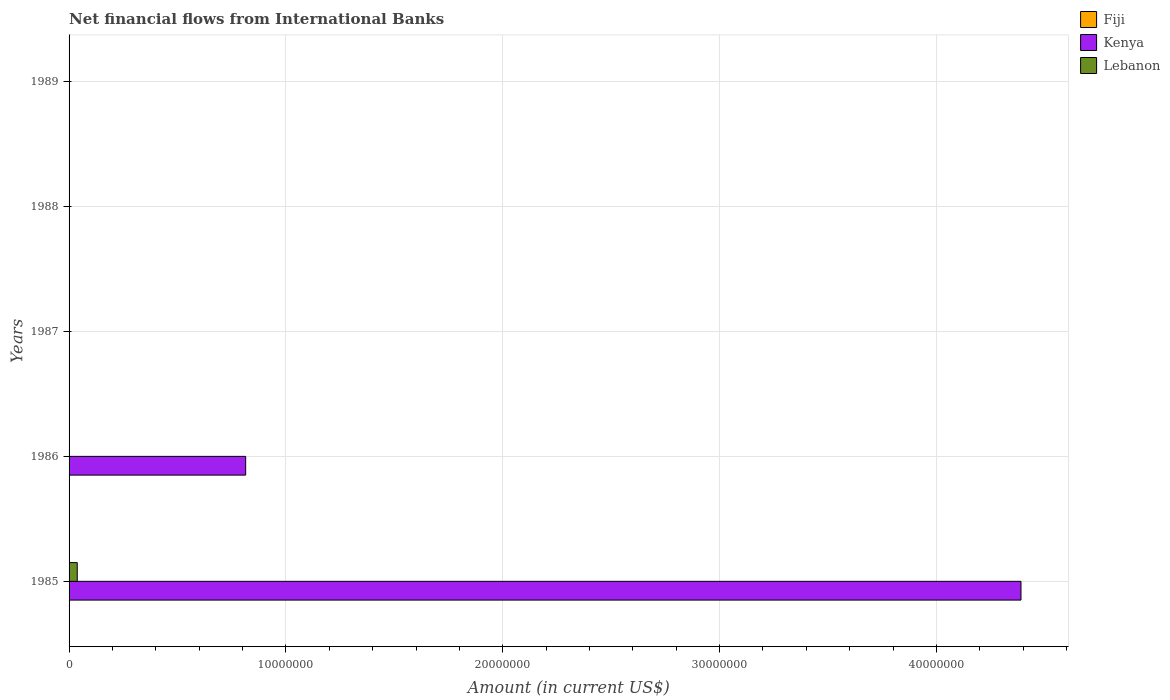How many bars are there on the 1st tick from the top?
Provide a short and direct response. 0. How many bars are there on the 5th tick from the bottom?
Give a very brief answer. 0. In how many cases, is the number of bars for a given year not equal to the number of legend labels?
Give a very brief answer. 5. Across all years, what is the maximum net financial aid flows in Lebanon?
Your response must be concise. 3.77e+05. Across all years, what is the minimum net financial aid flows in Lebanon?
Offer a very short reply. 0. What is the total net financial aid flows in Lebanon in the graph?
Give a very brief answer. 3.77e+05. What is the difference between the net financial aid flows in Kenya in 1987 and the net financial aid flows in Fiji in 1986?
Offer a terse response. 0. What is the average net financial aid flows in Fiji per year?
Keep it short and to the point. 0. In the year 1985, what is the difference between the net financial aid flows in Lebanon and net financial aid flows in Kenya?
Offer a terse response. -4.35e+07. What is the difference between the highest and the lowest net financial aid flows in Kenya?
Ensure brevity in your answer.  4.39e+07. How many bars are there?
Your answer should be compact. 3. How many years are there in the graph?
Provide a succinct answer. 5. What is the difference between two consecutive major ticks on the X-axis?
Provide a short and direct response. 1.00e+07. Does the graph contain grids?
Provide a short and direct response. Yes. Where does the legend appear in the graph?
Make the answer very short. Top right. How are the legend labels stacked?
Make the answer very short. Vertical. What is the title of the graph?
Give a very brief answer. Net financial flows from International Banks. What is the label or title of the X-axis?
Provide a succinct answer. Amount (in current US$). What is the Amount (in current US$) of Fiji in 1985?
Your answer should be compact. 0. What is the Amount (in current US$) of Kenya in 1985?
Provide a succinct answer. 4.39e+07. What is the Amount (in current US$) in Lebanon in 1985?
Ensure brevity in your answer.  3.77e+05. What is the Amount (in current US$) in Kenya in 1986?
Ensure brevity in your answer.  8.14e+06. What is the Amount (in current US$) of Kenya in 1987?
Keep it short and to the point. 0. What is the Amount (in current US$) of Fiji in 1988?
Offer a very short reply. 0. What is the Amount (in current US$) of Lebanon in 1989?
Give a very brief answer. 0. Across all years, what is the maximum Amount (in current US$) in Kenya?
Keep it short and to the point. 4.39e+07. Across all years, what is the maximum Amount (in current US$) in Lebanon?
Provide a short and direct response. 3.77e+05. Across all years, what is the minimum Amount (in current US$) of Kenya?
Offer a very short reply. 0. What is the total Amount (in current US$) of Fiji in the graph?
Your answer should be compact. 0. What is the total Amount (in current US$) in Kenya in the graph?
Your response must be concise. 5.20e+07. What is the total Amount (in current US$) of Lebanon in the graph?
Your response must be concise. 3.77e+05. What is the difference between the Amount (in current US$) in Kenya in 1985 and that in 1986?
Keep it short and to the point. 3.58e+07. What is the average Amount (in current US$) in Fiji per year?
Your answer should be compact. 0. What is the average Amount (in current US$) of Kenya per year?
Your answer should be very brief. 1.04e+07. What is the average Amount (in current US$) of Lebanon per year?
Offer a very short reply. 7.54e+04. In the year 1985, what is the difference between the Amount (in current US$) of Kenya and Amount (in current US$) of Lebanon?
Your answer should be compact. 4.35e+07. What is the ratio of the Amount (in current US$) in Kenya in 1985 to that in 1986?
Ensure brevity in your answer.  5.39. What is the difference between the highest and the lowest Amount (in current US$) in Kenya?
Give a very brief answer. 4.39e+07. What is the difference between the highest and the lowest Amount (in current US$) in Lebanon?
Keep it short and to the point. 3.77e+05. 